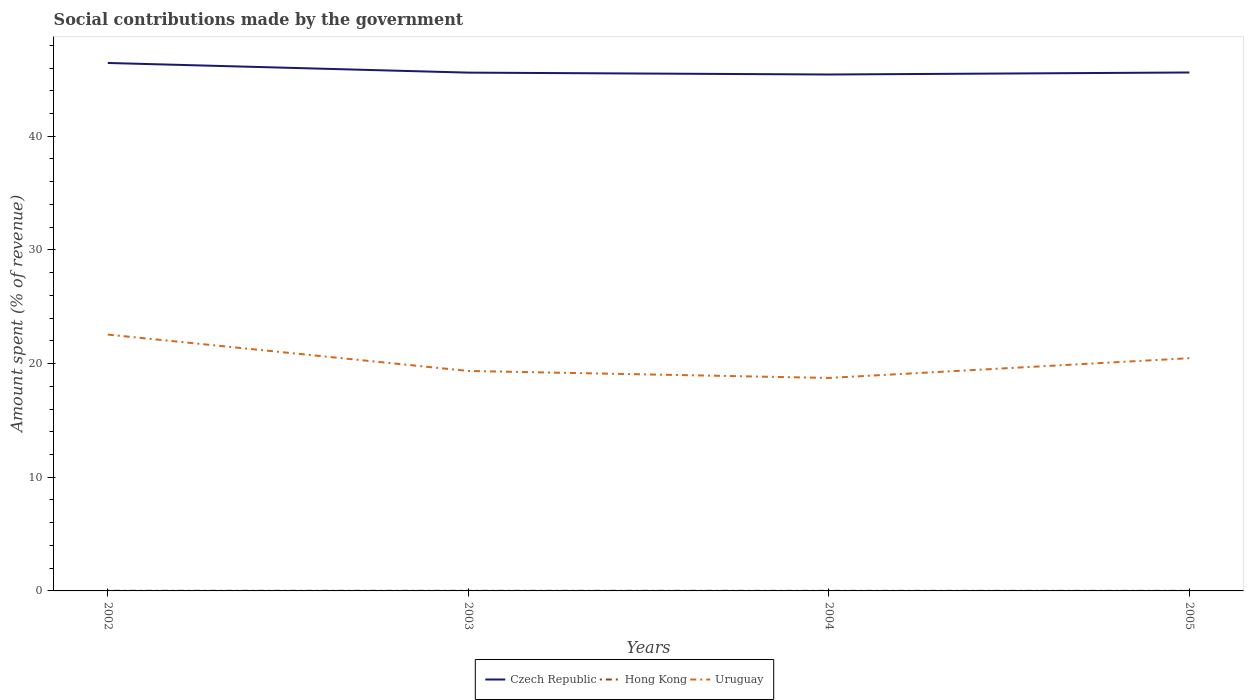How many different coloured lines are there?
Your answer should be compact. 3. Does the line corresponding to Hong Kong intersect with the line corresponding to Uruguay?
Offer a terse response. No. Is the number of lines equal to the number of legend labels?
Provide a succinct answer. Yes. Across all years, what is the maximum amount spent (in %) on social contributions in Uruguay?
Provide a succinct answer. 18.74. What is the total amount spent (in %) on social contributions in Uruguay in the graph?
Your answer should be compact. 3.81. What is the difference between the highest and the second highest amount spent (in %) on social contributions in Czech Republic?
Offer a terse response. 1.01. Is the amount spent (in %) on social contributions in Uruguay strictly greater than the amount spent (in %) on social contributions in Hong Kong over the years?
Give a very brief answer. No. How many lines are there?
Your response must be concise. 3. How many years are there in the graph?
Your answer should be compact. 4. Are the values on the major ticks of Y-axis written in scientific E-notation?
Ensure brevity in your answer.  No. Does the graph contain any zero values?
Your answer should be very brief. No. Does the graph contain grids?
Make the answer very short. No. Where does the legend appear in the graph?
Ensure brevity in your answer.  Bottom center. How many legend labels are there?
Your answer should be very brief. 3. What is the title of the graph?
Make the answer very short. Social contributions made by the government. What is the label or title of the Y-axis?
Your answer should be very brief. Amount spent (% of revenue). What is the Amount spent (% of revenue) in Czech Republic in 2002?
Offer a terse response. 46.44. What is the Amount spent (% of revenue) of Hong Kong in 2002?
Keep it short and to the point. 0.01. What is the Amount spent (% of revenue) of Uruguay in 2002?
Make the answer very short. 22.55. What is the Amount spent (% of revenue) of Czech Republic in 2003?
Keep it short and to the point. 45.6. What is the Amount spent (% of revenue) in Hong Kong in 2003?
Your response must be concise. 0.01. What is the Amount spent (% of revenue) in Uruguay in 2003?
Offer a very short reply. 19.35. What is the Amount spent (% of revenue) of Czech Republic in 2004?
Your answer should be compact. 45.43. What is the Amount spent (% of revenue) in Hong Kong in 2004?
Provide a succinct answer. 0.01. What is the Amount spent (% of revenue) in Uruguay in 2004?
Keep it short and to the point. 18.74. What is the Amount spent (% of revenue) in Czech Republic in 2005?
Your response must be concise. 45.61. What is the Amount spent (% of revenue) of Hong Kong in 2005?
Provide a short and direct response. 0.01. What is the Amount spent (% of revenue) of Uruguay in 2005?
Your answer should be compact. 20.47. Across all years, what is the maximum Amount spent (% of revenue) in Czech Republic?
Offer a terse response. 46.44. Across all years, what is the maximum Amount spent (% of revenue) in Hong Kong?
Offer a terse response. 0.01. Across all years, what is the maximum Amount spent (% of revenue) in Uruguay?
Keep it short and to the point. 22.55. Across all years, what is the minimum Amount spent (% of revenue) of Czech Republic?
Ensure brevity in your answer.  45.43. Across all years, what is the minimum Amount spent (% of revenue) of Hong Kong?
Offer a very short reply. 0.01. Across all years, what is the minimum Amount spent (% of revenue) of Uruguay?
Give a very brief answer. 18.74. What is the total Amount spent (% of revenue) of Czech Republic in the graph?
Ensure brevity in your answer.  183.08. What is the total Amount spent (% of revenue) in Hong Kong in the graph?
Offer a very short reply. 0.04. What is the total Amount spent (% of revenue) of Uruguay in the graph?
Offer a very short reply. 81.11. What is the difference between the Amount spent (% of revenue) of Czech Republic in 2002 and that in 2003?
Ensure brevity in your answer.  0.85. What is the difference between the Amount spent (% of revenue) of Hong Kong in 2002 and that in 2003?
Offer a very short reply. 0. What is the difference between the Amount spent (% of revenue) of Uruguay in 2002 and that in 2003?
Offer a terse response. 3.2. What is the difference between the Amount spent (% of revenue) in Hong Kong in 2002 and that in 2004?
Make the answer very short. 0.01. What is the difference between the Amount spent (% of revenue) of Uruguay in 2002 and that in 2004?
Provide a succinct answer. 3.81. What is the difference between the Amount spent (% of revenue) in Czech Republic in 2002 and that in 2005?
Keep it short and to the point. 0.84. What is the difference between the Amount spent (% of revenue) in Hong Kong in 2002 and that in 2005?
Your answer should be very brief. 0.01. What is the difference between the Amount spent (% of revenue) in Uruguay in 2002 and that in 2005?
Your response must be concise. 2.08. What is the difference between the Amount spent (% of revenue) in Czech Republic in 2003 and that in 2004?
Provide a short and direct response. 0.17. What is the difference between the Amount spent (% of revenue) in Hong Kong in 2003 and that in 2004?
Make the answer very short. 0. What is the difference between the Amount spent (% of revenue) in Uruguay in 2003 and that in 2004?
Keep it short and to the point. 0.61. What is the difference between the Amount spent (% of revenue) in Czech Republic in 2003 and that in 2005?
Offer a terse response. -0.01. What is the difference between the Amount spent (% of revenue) in Hong Kong in 2003 and that in 2005?
Provide a succinct answer. 0. What is the difference between the Amount spent (% of revenue) of Uruguay in 2003 and that in 2005?
Offer a very short reply. -1.12. What is the difference between the Amount spent (% of revenue) in Czech Republic in 2004 and that in 2005?
Your answer should be compact. -0.18. What is the difference between the Amount spent (% of revenue) of Hong Kong in 2004 and that in 2005?
Your answer should be very brief. 0. What is the difference between the Amount spent (% of revenue) in Uruguay in 2004 and that in 2005?
Your response must be concise. -1.74. What is the difference between the Amount spent (% of revenue) in Czech Republic in 2002 and the Amount spent (% of revenue) in Hong Kong in 2003?
Your response must be concise. 46.43. What is the difference between the Amount spent (% of revenue) in Czech Republic in 2002 and the Amount spent (% of revenue) in Uruguay in 2003?
Keep it short and to the point. 27.09. What is the difference between the Amount spent (% of revenue) in Hong Kong in 2002 and the Amount spent (% of revenue) in Uruguay in 2003?
Provide a succinct answer. -19.34. What is the difference between the Amount spent (% of revenue) of Czech Republic in 2002 and the Amount spent (% of revenue) of Hong Kong in 2004?
Your response must be concise. 46.44. What is the difference between the Amount spent (% of revenue) in Czech Republic in 2002 and the Amount spent (% of revenue) in Uruguay in 2004?
Ensure brevity in your answer.  27.71. What is the difference between the Amount spent (% of revenue) in Hong Kong in 2002 and the Amount spent (% of revenue) in Uruguay in 2004?
Offer a terse response. -18.72. What is the difference between the Amount spent (% of revenue) of Czech Republic in 2002 and the Amount spent (% of revenue) of Hong Kong in 2005?
Make the answer very short. 46.44. What is the difference between the Amount spent (% of revenue) of Czech Republic in 2002 and the Amount spent (% of revenue) of Uruguay in 2005?
Your answer should be very brief. 25.97. What is the difference between the Amount spent (% of revenue) in Hong Kong in 2002 and the Amount spent (% of revenue) in Uruguay in 2005?
Your answer should be very brief. -20.46. What is the difference between the Amount spent (% of revenue) in Czech Republic in 2003 and the Amount spent (% of revenue) in Hong Kong in 2004?
Offer a very short reply. 45.59. What is the difference between the Amount spent (% of revenue) in Czech Republic in 2003 and the Amount spent (% of revenue) in Uruguay in 2004?
Give a very brief answer. 26.86. What is the difference between the Amount spent (% of revenue) in Hong Kong in 2003 and the Amount spent (% of revenue) in Uruguay in 2004?
Provide a succinct answer. -18.72. What is the difference between the Amount spent (% of revenue) in Czech Republic in 2003 and the Amount spent (% of revenue) in Hong Kong in 2005?
Offer a very short reply. 45.59. What is the difference between the Amount spent (% of revenue) in Czech Republic in 2003 and the Amount spent (% of revenue) in Uruguay in 2005?
Provide a short and direct response. 25.12. What is the difference between the Amount spent (% of revenue) in Hong Kong in 2003 and the Amount spent (% of revenue) in Uruguay in 2005?
Offer a terse response. -20.46. What is the difference between the Amount spent (% of revenue) of Czech Republic in 2004 and the Amount spent (% of revenue) of Hong Kong in 2005?
Offer a terse response. 45.42. What is the difference between the Amount spent (% of revenue) in Czech Republic in 2004 and the Amount spent (% of revenue) in Uruguay in 2005?
Your answer should be very brief. 24.96. What is the difference between the Amount spent (% of revenue) of Hong Kong in 2004 and the Amount spent (% of revenue) of Uruguay in 2005?
Give a very brief answer. -20.47. What is the average Amount spent (% of revenue) of Czech Republic per year?
Your answer should be compact. 45.77. What is the average Amount spent (% of revenue) in Hong Kong per year?
Give a very brief answer. 0.01. What is the average Amount spent (% of revenue) in Uruguay per year?
Your answer should be very brief. 20.28. In the year 2002, what is the difference between the Amount spent (% of revenue) in Czech Republic and Amount spent (% of revenue) in Hong Kong?
Ensure brevity in your answer.  46.43. In the year 2002, what is the difference between the Amount spent (% of revenue) of Czech Republic and Amount spent (% of revenue) of Uruguay?
Ensure brevity in your answer.  23.89. In the year 2002, what is the difference between the Amount spent (% of revenue) in Hong Kong and Amount spent (% of revenue) in Uruguay?
Offer a very short reply. -22.54. In the year 2003, what is the difference between the Amount spent (% of revenue) in Czech Republic and Amount spent (% of revenue) in Hong Kong?
Provide a short and direct response. 45.58. In the year 2003, what is the difference between the Amount spent (% of revenue) in Czech Republic and Amount spent (% of revenue) in Uruguay?
Keep it short and to the point. 26.25. In the year 2003, what is the difference between the Amount spent (% of revenue) of Hong Kong and Amount spent (% of revenue) of Uruguay?
Ensure brevity in your answer.  -19.34. In the year 2004, what is the difference between the Amount spent (% of revenue) in Czech Republic and Amount spent (% of revenue) in Hong Kong?
Keep it short and to the point. 45.42. In the year 2004, what is the difference between the Amount spent (% of revenue) in Czech Republic and Amount spent (% of revenue) in Uruguay?
Provide a short and direct response. 26.69. In the year 2004, what is the difference between the Amount spent (% of revenue) of Hong Kong and Amount spent (% of revenue) of Uruguay?
Your response must be concise. -18.73. In the year 2005, what is the difference between the Amount spent (% of revenue) in Czech Republic and Amount spent (% of revenue) in Hong Kong?
Provide a short and direct response. 45.6. In the year 2005, what is the difference between the Amount spent (% of revenue) of Czech Republic and Amount spent (% of revenue) of Uruguay?
Ensure brevity in your answer.  25.13. In the year 2005, what is the difference between the Amount spent (% of revenue) of Hong Kong and Amount spent (% of revenue) of Uruguay?
Provide a succinct answer. -20.47. What is the ratio of the Amount spent (% of revenue) in Czech Republic in 2002 to that in 2003?
Provide a short and direct response. 1.02. What is the ratio of the Amount spent (% of revenue) of Hong Kong in 2002 to that in 2003?
Ensure brevity in your answer.  1.21. What is the ratio of the Amount spent (% of revenue) of Uruguay in 2002 to that in 2003?
Make the answer very short. 1.17. What is the ratio of the Amount spent (% of revenue) in Czech Republic in 2002 to that in 2004?
Make the answer very short. 1.02. What is the ratio of the Amount spent (% of revenue) of Hong Kong in 2002 to that in 2004?
Your answer should be very brief. 1.68. What is the ratio of the Amount spent (% of revenue) of Uruguay in 2002 to that in 2004?
Give a very brief answer. 1.2. What is the ratio of the Amount spent (% of revenue) in Czech Republic in 2002 to that in 2005?
Your response must be concise. 1.02. What is the ratio of the Amount spent (% of revenue) of Hong Kong in 2002 to that in 2005?
Your answer should be very brief. 2.1. What is the ratio of the Amount spent (% of revenue) of Uruguay in 2002 to that in 2005?
Make the answer very short. 1.1. What is the ratio of the Amount spent (% of revenue) in Czech Republic in 2003 to that in 2004?
Make the answer very short. 1. What is the ratio of the Amount spent (% of revenue) in Hong Kong in 2003 to that in 2004?
Your answer should be compact. 1.39. What is the ratio of the Amount spent (% of revenue) of Uruguay in 2003 to that in 2004?
Provide a succinct answer. 1.03. What is the ratio of the Amount spent (% of revenue) in Czech Republic in 2003 to that in 2005?
Provide a short and direct response. 1. What is the ratio of the Amount spent (% of revenue) in Hong Kong in 2003 to that in 2005?
Offer a terse response. 1.73. What is the ratio of the Amount spent (% of revenue) in Uruguay in 2003 to that in 2005?
Keep it short and to the point. 0.95. What is the ratio of the Amount spent (% of revenue) of Hong Kong in 2004 to that in 2005?
Provide a short and direct response. 1.25. What is the ratio of the Amount spent (% of revenue) of Uruguay in 2004 to that in 2005?
Offer a terse response. 0.92. What is the difference between the highest and the second highest Amount spent (% of revenue) in Czech Republic?
Provide a succinct answer. 0.84. What is the difference between the highest and the second highest Amount spent (% of revenue) in Hong Kong?
Give a very brief answer. 0. What is the difference between the highest and the second highest Amount spent (% of revenue) in Uruguay?
Ensure brevity in your answer.  2.08. What is the difference between the highest and the lowest Amount spent (% of revenue) in Hong Kong?
Your answer should be very brief. 0.01. What is the difference between the highest and the lowest Amount spent (% of revenue) of Uruguay?
Provide a succinct answer. 3.81. 